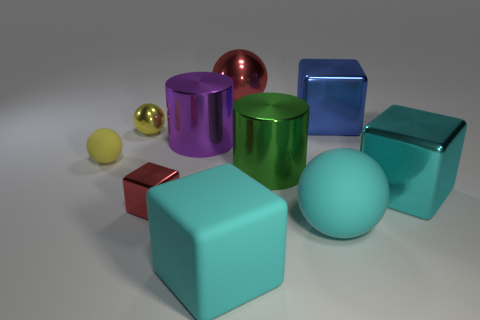Subtract 1 spheres. How many spheres are left? 3 Subtract all blue blocks. How many blocks are left? 3 Subtract all brown blocks. Subtract all red cylinders. How many blocks are left? 4 Subtract all cylinders. How many objects are left? 8 Subtract all cyan things. Subtract all yellow shiny cubes. How many objects are left? 7 Add 9 red cubes. How many red cubes are left? 10 Add 3 red rubber cubes. How many red rubber cubes exist? 3 Subtract 0 yellow cubes. How many objects are left? 10 